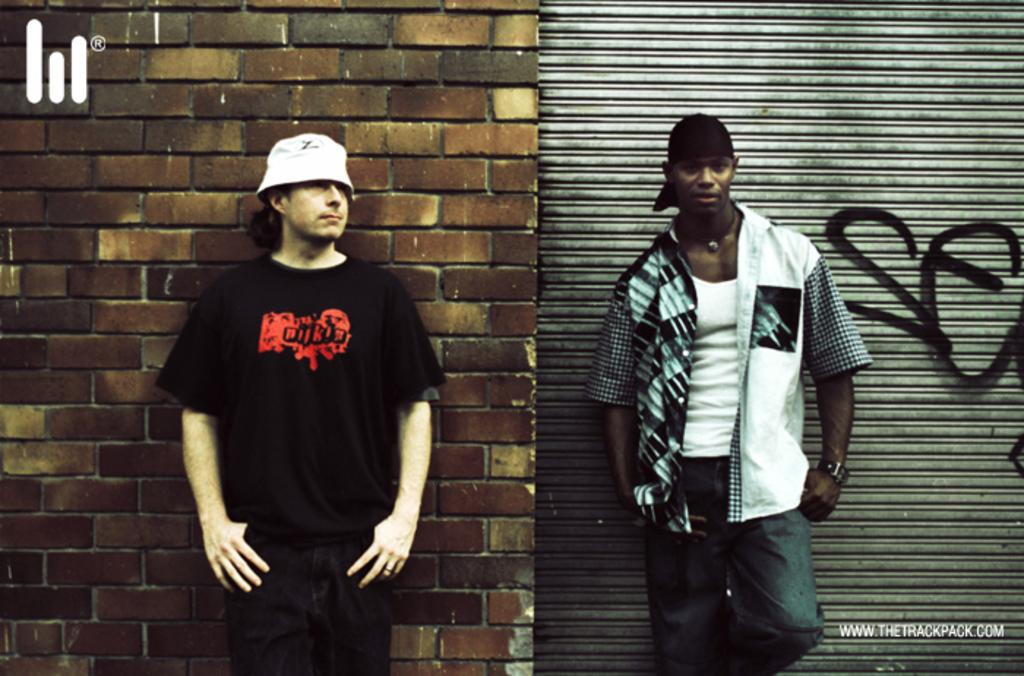How many people are present in the image? There are two men standing in the image. What is located behind the men? There is a wall behind the men. Can you describe any specific features in the image? Yes, there is a roller shutter in the image. Are there any additional elements that might not be immediately noticeable? The image contains watermarks. What type of letter is the goose holding in the image? There is no goose or letter present in the image. Is there a hook attached to the roller shutter in the image? The image does not show any hooks attached to the roller shutter. 